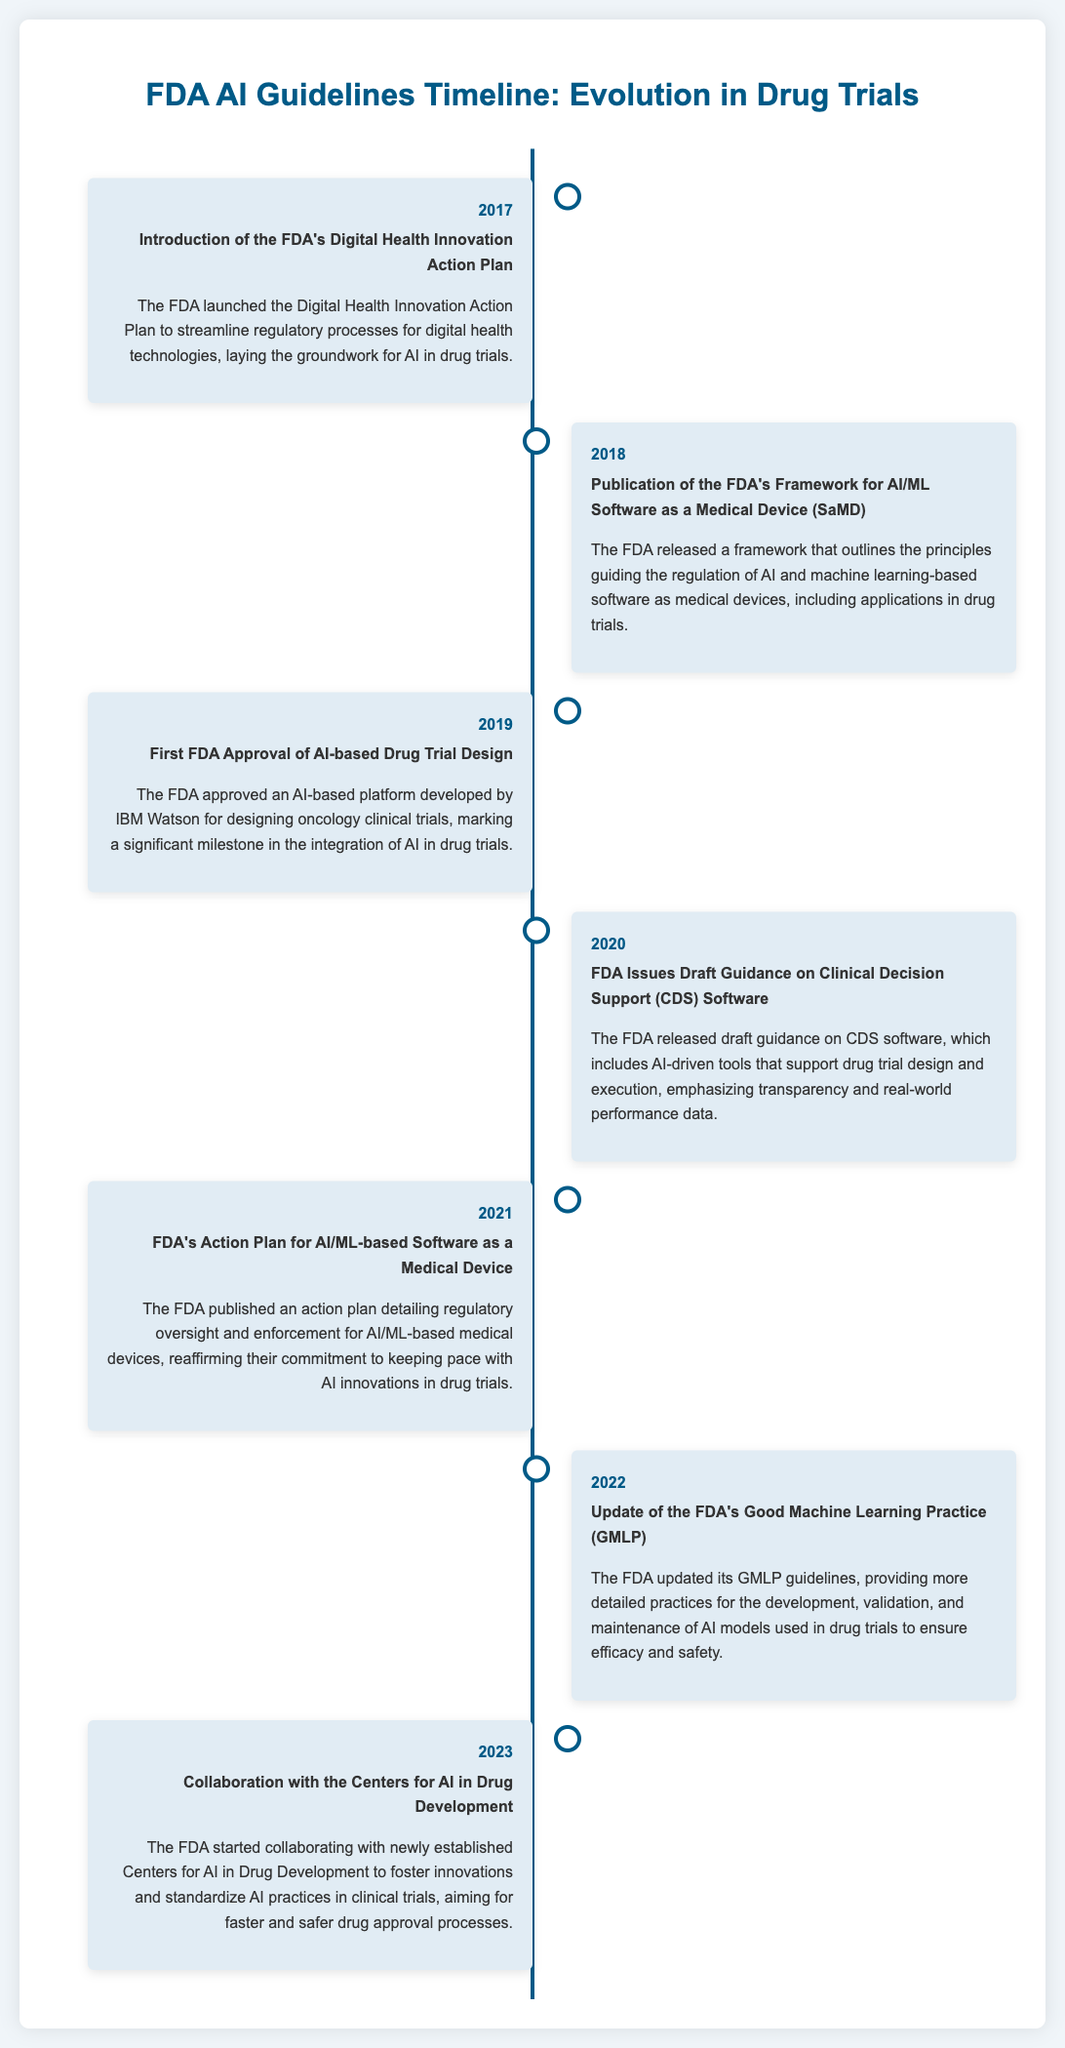what year was the FDA's Digital Health Innovation Action Plan introduced? The document states that the FDA launched the Digital Health Innovation Action Plan in 2017.
Answer: 2017 what significant approval did the FDA grant in 2019? The document mentions that in 2019, the FDA approved an AI-based platform developed by IBM Watson for designing oncology clinical trials.
Answer: AI-based platform what is the main focus of the FDA's action plan published in 2021? The action plan published in 2021 details regulatory oversight and enforcement for AI/ML-based medical devices, ensuring they keep pace with innovations in drug trials.
Answer: Regulatory oversight which year did the FDA release draft guidance on Clinical Decision Support Software? According to the timeline, the FDA issued draft guidance on Clinical Decision Support Software in 2020.
Answer: 2020 what was updated by the FDA in 2022? The document states that the FDA updated its Good Machine Learning Practice (GMLP) guidelines in 2022.
Answer: Good Machine Learning Practice what is the purpose of the collaboration started by the FDA in 2023? The collaboration with newly established Centers for AI in Drug Development aims to foster innovations and standardize AI practices in clinical trials.
Answer: Foster innovations what did the FDA's Framework for AI/ML Software aim to outline? The document notes that the published framework outlines the principles guiding the regulation of AI and machine learning-based software as medical devices.
Answer: Regulation principles which agency is prominently featured as collaborating with the FDA for AI in drug development? According to the timeline, the FDA started collaborating with the Centers for AI in Drug Development.
Answer: Centers for AI in Drug Development 